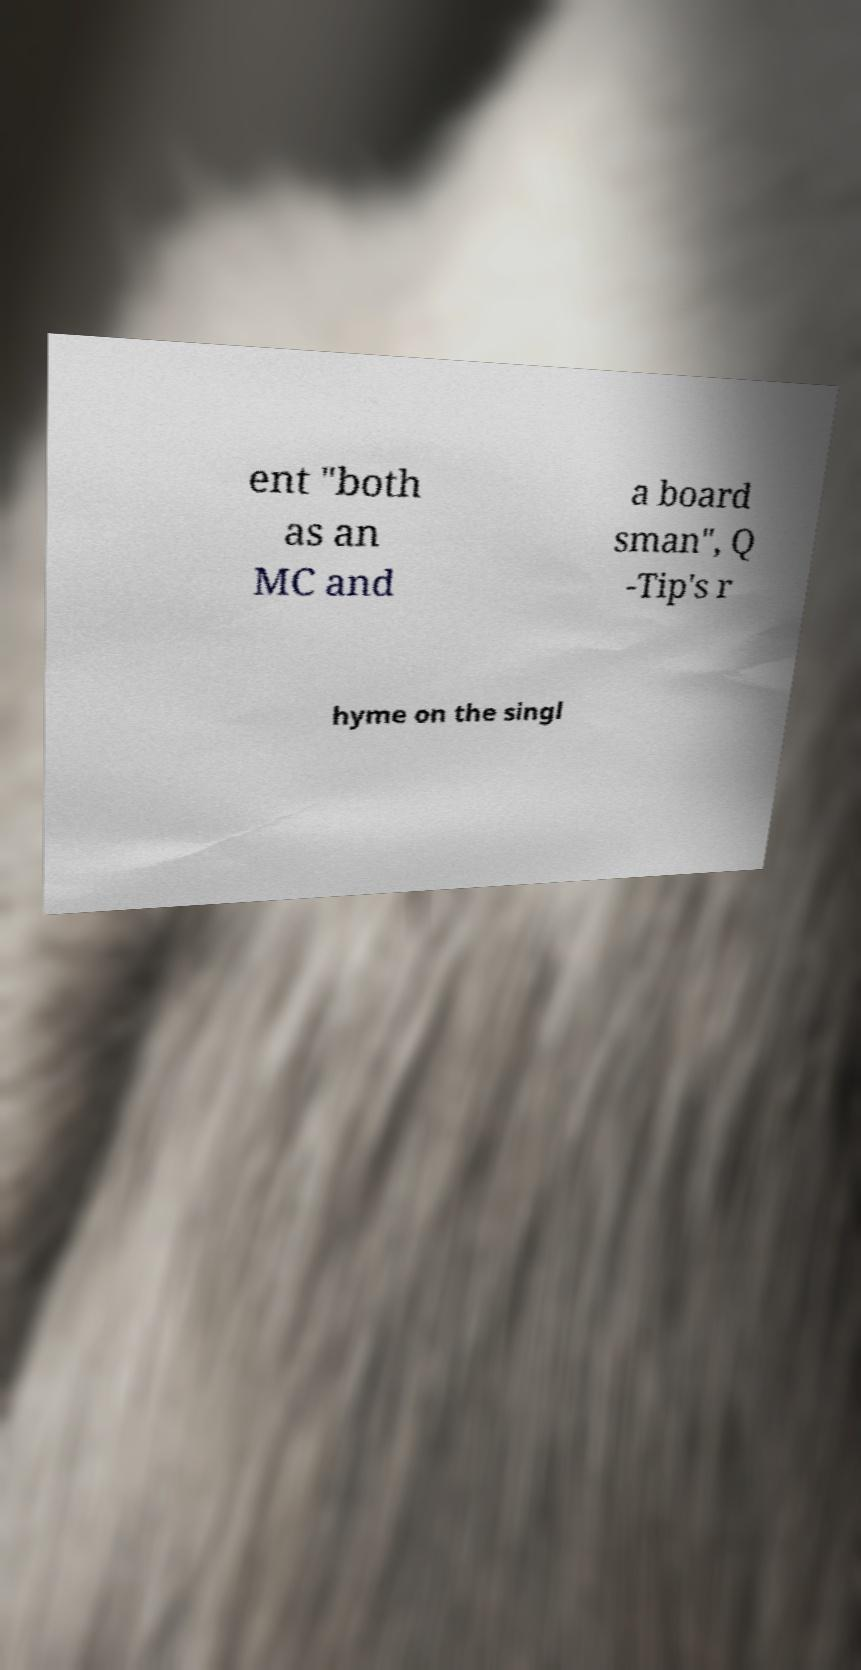Could you assist in decoding the text presented in this image and type it out clearly? ent "both as an MC and a board sman", Q -Tip's r hyme on the singl 